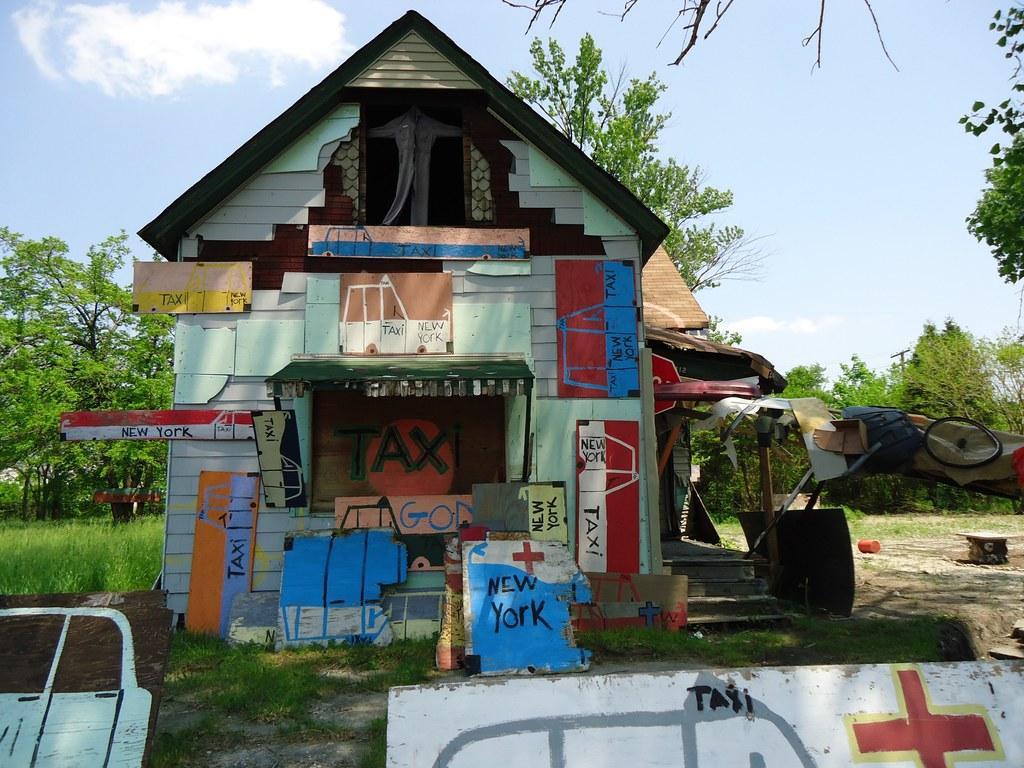Can you describe this image briefly? In the center of the image there is a shed and we can see boards. In the background there is a tent, trees, pole and sky. 